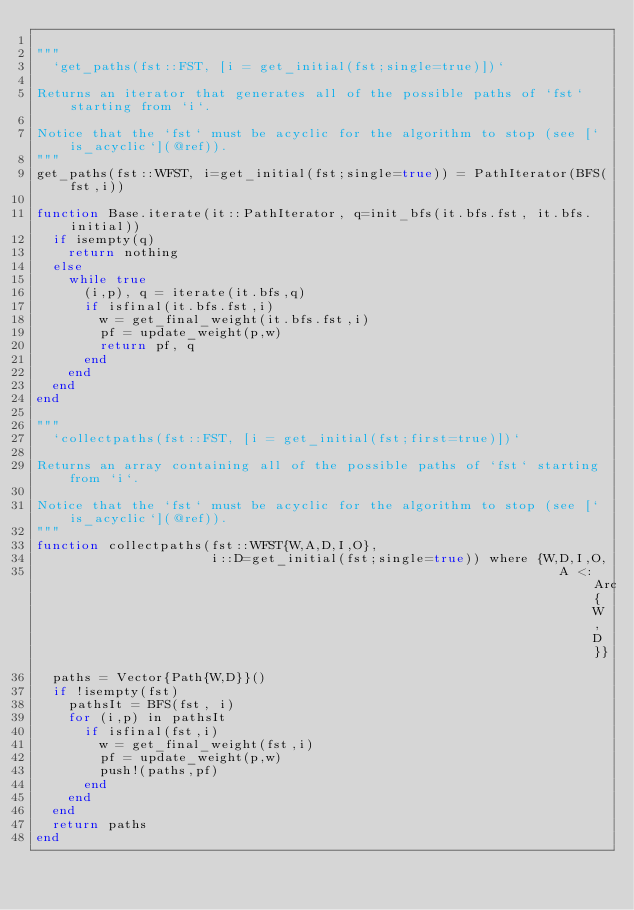Convert code to text. <code><loc_0><loc_0><loc_500><loc_500><_Julia_>
"""
  `get_paths(fst::FST, [i = get_initial(fst;single=true)])`

Returns an iterator that generates all of the possible paths of `fst` starting from `i`.

Notice that the `fst` must be acyclic for the algorithm to stop (see [`is_acyclic`](@ref)).
"""
get_paths(fst::WFST, i=get_initial(fst;single=true)) = PathIterator(BFS(fst,i))

function Base.iterate(it::PathIterator, q=init_bfs(it.bfs.fst, it.bfs.initial))
  if isempty(q)
    return nothing
  else
    while true
      (i,p), q = iterate(it.bfs,q)
      if isfinal(it.bfs.fst,i)
        w = get_final_weight(it.bfs.fst,i)
        pf = update_weight(p,w)
        return pf, q
      end
    end
  end
end

"""
  `collectpaths(fst::FST, [i = get_initial(fst;first=true)])`

Returns an array containing all of the possible paths of `fst` starting from `i`.

Notice that the `fst` must be acyclic for the algorithm to stop (see [`is_acyclic`](@ref)).
"""
function collectpaths(fst::WFST{W,A,D,I,O}, 
                      i::D=get_initial(fst;single=true)) where {W,D,I,O, 
                                                                  A <: Arc{W,D}}
  paths = Vector{Path{W,D}}()
  if !isempty(fst)
    pathsIt = BFS(fst, i)
    for (i,p) in pathsIt
      if isfinal(fst,i)
        w = get_final_weight(fst,i)
        pf = update_weight(p,w)
        push!(paths,pf)
      end
    end
  end
  return paths
end
</code> 